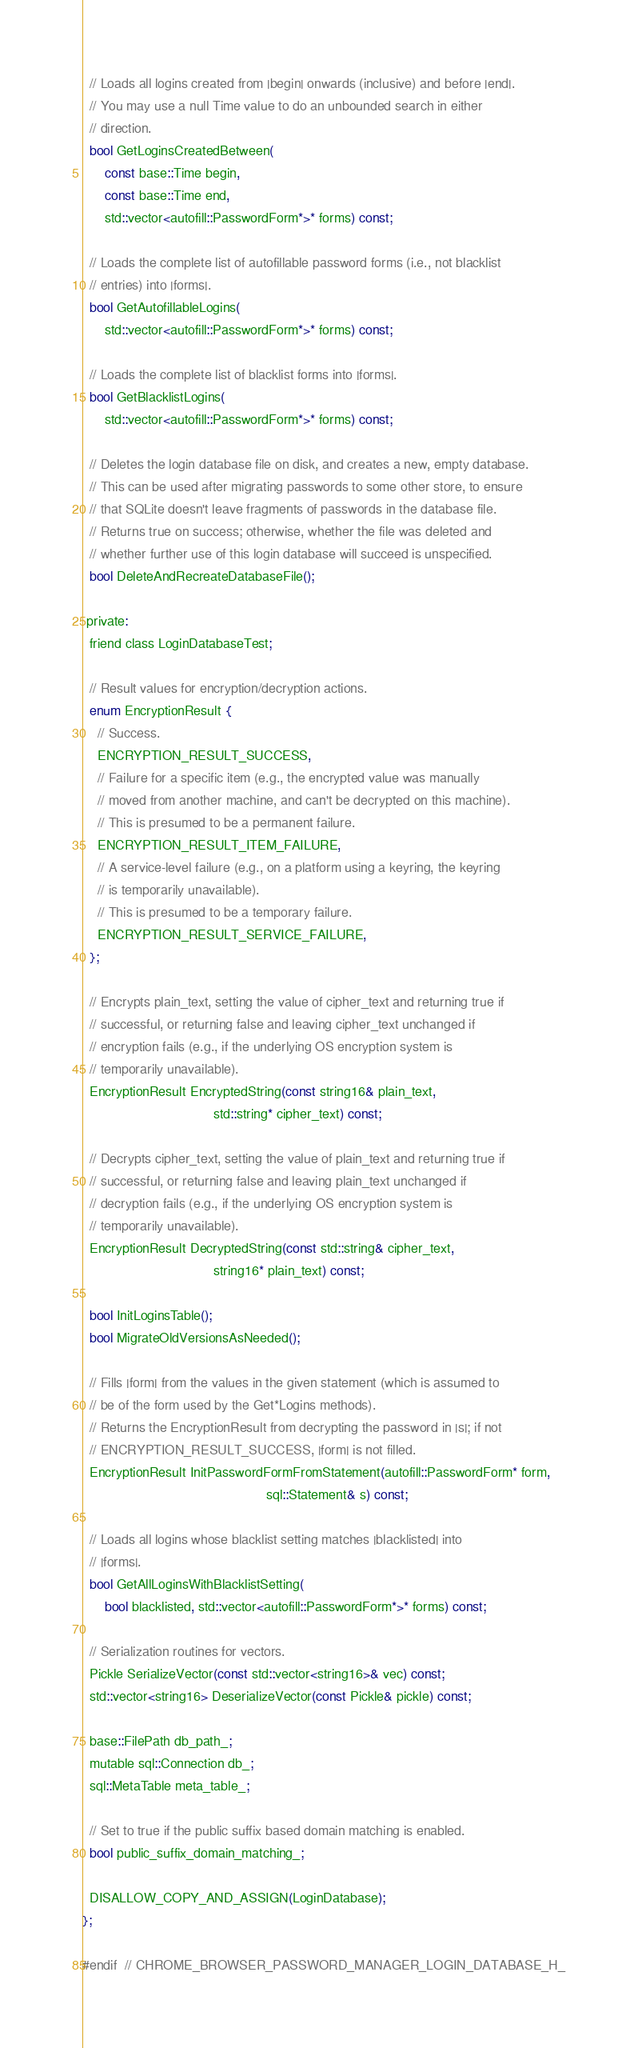Convert code to text. <code><loc_0><loc_0><loc_500><loc_500><_C_>
  // Loads all logins created from |begin| onwards (inclusive) and before |end|.
  // You may use a null Time value to do an unbounded search in either
  // direction.
  bool GetLoginsCreatedBetween(
      const base::Time begin,
      const base::Time end,
      std::vector<autofill::PasswordForm*>* forms) const;

  // Loads the complete list of autofillable password forms (i.e., not blacklist
  // entries) into |forms|.
  bool GetAutofillableLogins(
      std::vector<autofill::PasswordForm*>* forms) const;

  // Loads the complete list of blacklist forms into |forms|.
  bool GetBlacklistLogins(
      std::vector<autofill::PasswordForm*>* forms) const;

  // Deletes the login database file on disk, and creates a new, empty database.
  // This can be used after migrating passwords to some other store, to ensure
  // that SQLite doesn't leave fragments of passwords in the database file.
  // Returns true on success; otherwise, whether the file was deleted and
  // whether further use of this login database will succeed is unspecified.
  bool DeleteAndRecreateDatabaseFile();

 private:
  friend class LoginDatabaseTest;

  // Result values for encryption/decryption actions.
  enum EncryptionResult {
    // Success.
    ENCRYPTION_RESULT_SUCCESS,
    // Failure for a specific item (e.g., the encrypted value was manually
    // moved from another machine, and can't be decrypted on this machine).
    // This is presumed to be a permanent failure.
    ENCRYPTION_RESULT_ITEM_FAILURE,
    // A service-level failure (e.g., on a platform using a keyring, the keyring
    // is temporarily unavailable).
    // This is presumed to be a temporary failure.
    ENCRYPTION_RESULT_SERVICE_FAILURE,
  };

  // Encrypts plain_text, setting the value of cipher_text and returning true if
  // successful, or returning false and leaving cipher_text unchanged if
  // encryption fails (e.g., if the underlying OS encryption system is
  // temporarily unavailable).
  EncryptionResult EncryptedString(const string16& plain_text,
                                   std::string* cipher_text) const;

  // Decrypts cipher_text, setting the value of plain_text and returning true if
  // successful, or returning false and leaving plain_text unchanged if
  // decryption fails (e.g., if the underlying OS encryption system is
  // temporarily unavailable).
  EncryptionResult DecryptedString(const std::string& cipher_text,
                                   string16* plain_text) const;

  bool InitLoginsTable();
  bool MigrateOldVersionsAsNeeded();

  // Fills |form| from the values in the given statement (which is assumed to
  // be of the form used by the Get*Logins methods).
  // Returns the EncryptionResult from decrypting the password in |s|; if not
  // ENCRYPTION_RESULT_SUCCESS, |form| is not filled.
  EncryptionResult InitPasswordFormFromStatement(autofill::PasswordForm* form,
                                                 sql::Statement& s) const;

  // Loads all logins whose blacklist setting matches |blacklisted| into
  // |forms|.
  bool GetAllLoginsWithBlacklistSetting(
      bool blacklisted, std::vector<autofill::PasswordForm*>* forms) const;

  // Serialization routines for vectors.
  Pickle SerializeVector(const std::vector<string16>& vec) const;
  std::vector<string16> DeserializeVector(const Pickle& pickle) const;

  base::FilePath db_path_;
  mutable sql::Connection db_;
  sql::MetaTable meta_table_;

  // Set to true if the public suffix based domain matching is enabled.
  bool public_suffix_domain_matching_;

  DISALLOW_COPY_AND_ASSIGN(LoginDatabase);
};

#endif  // CHROME_BROWSER_PASSWORD_MANAGER_LOGIN_DATABASE_H_
</code> 